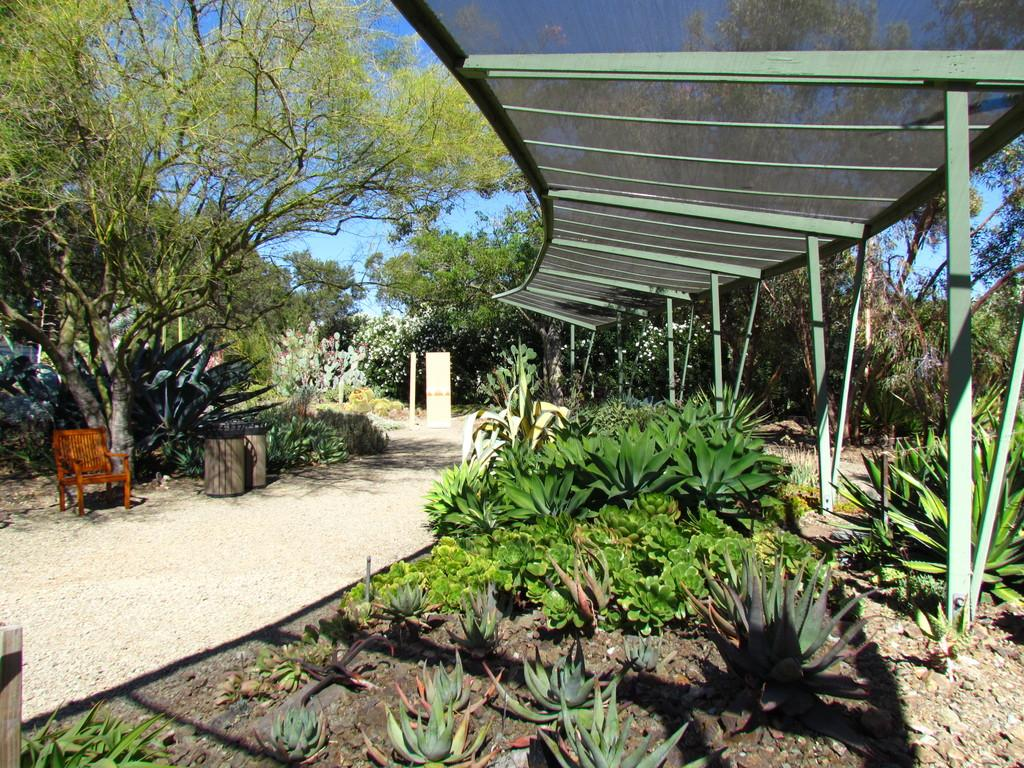What type of living organisms can be seen in the image? Plants can be seen in the image. What structures are present in the image? Poles and a chair are present in the image. What objects are used for waste disposal in the image? Dustbins are present in the image. What can be seen in the background of the image? Trees and the sky are visible in the background of the image. What direction is the bread facing in the image? There is no bread present in the image. What type of seed can be seen growing on the plants in the image? There is no mention of seeds in the image, only plants are mentioned. 